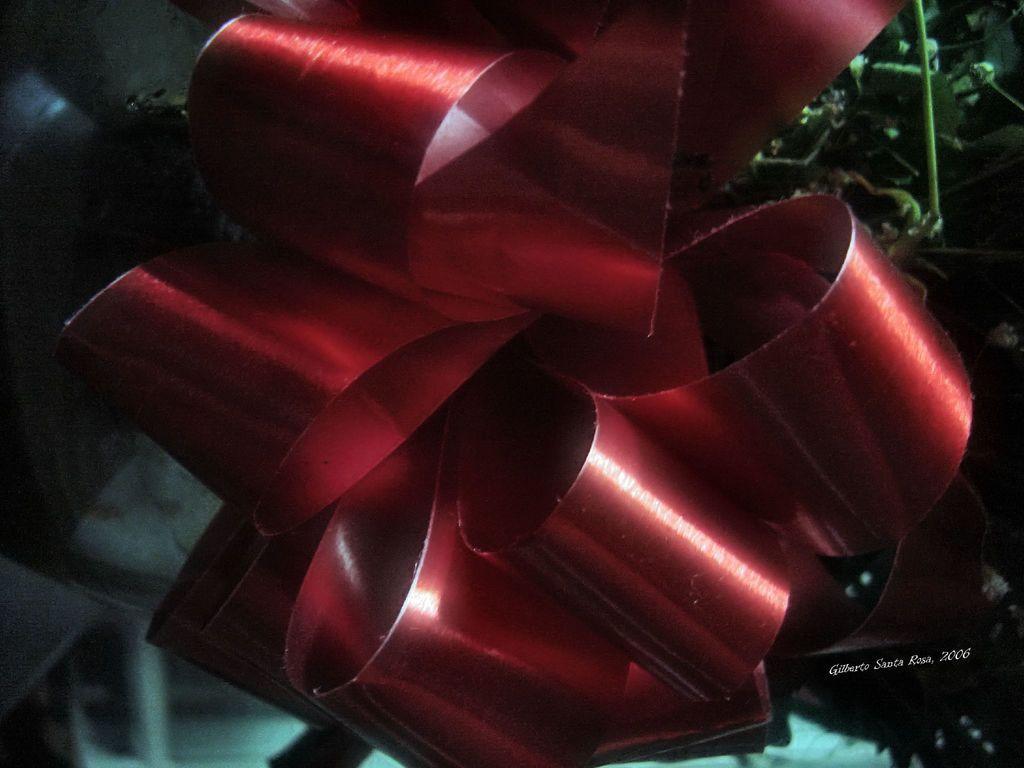How would you summarize this image in a sentence or two? In the picture I can see the decorating binding ribbon. 